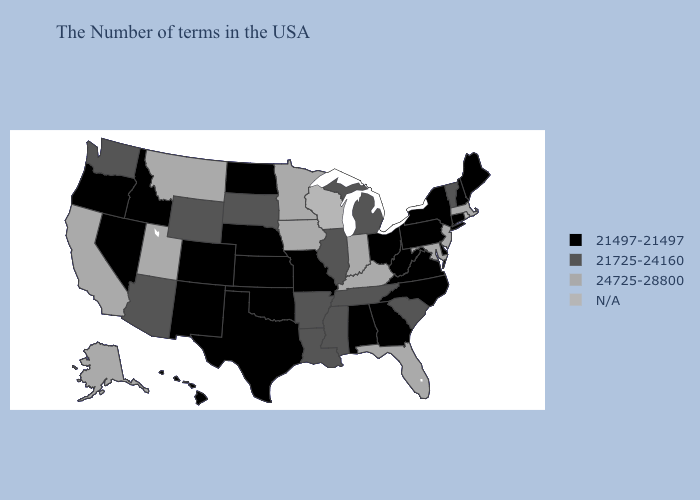What is the value of Idaho?
Short answer required. 21497-21497. Name the states that have a value in the range N/A?
Keep it brief. Rhode Island, Wisconsin. Among the states that border Nevada , does Oregon have the highest value?
Answer briefly. No. What is the lowest value in the MidWest?
Write a very short answer. 21497-21497. What is the value of Wisconsin?
Give a very brief answer. N/A. What is the lowest value in the USA?
Keep it brief. 21497-21497. Among the states that border Kansas , which have the lowest value?
Keep it brief. Missouri, Nebraska, Oklahoma, Colorado. What is the lowest value in states that border Tennessee?
Give a very brief answer. 21497-21497. What is the value of Washington?
Quick response, please. 21725-24160. Among the states that border Ohio , does Kentucky have the highest value?
Concise answer only. Yes. What is the highest value in the Northeast ?
Concise answer only. 24725-28800. Name the states that have a value in the range 21725-24160?
Give a very brief answer. Vermont, South Carolina, Michigan, Tennessee, Illinois, Mississippi, Louisiana, Arkansas, South Dakota, Wyoming, Arizona, Washington. 